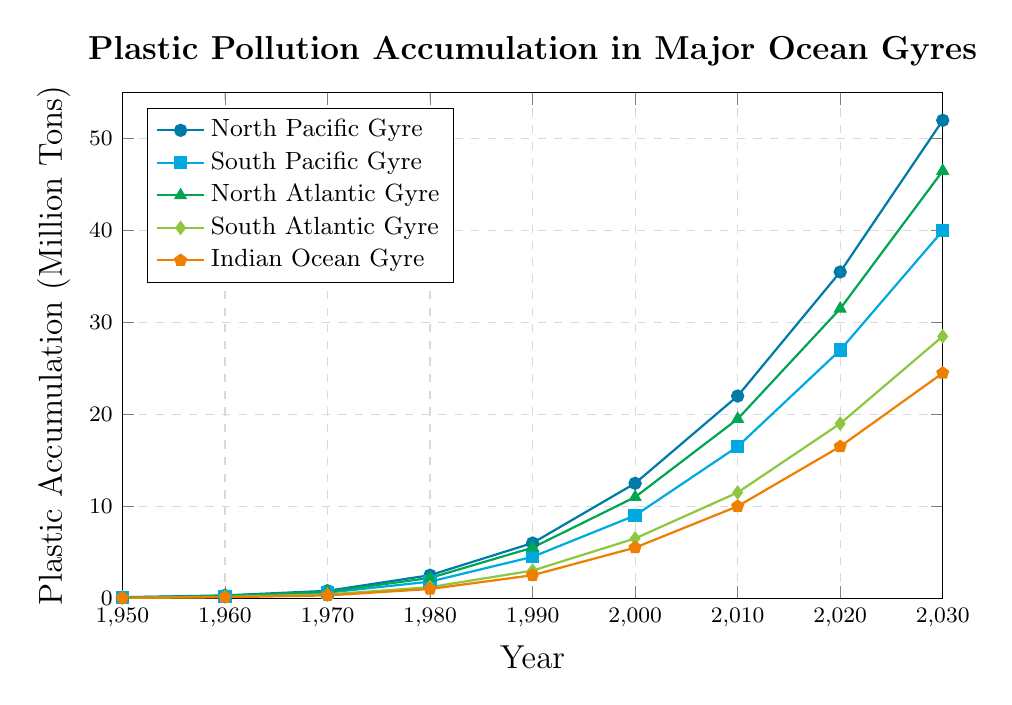What is the plastic accumulation in the North Pacific Gyre in 2020? Look for the data point corresponding to the North Pacific Gyre in the year 2020.
Answer: 35.5 million tons Which gyre has the highest plastic accumulation in the year 2030? Compare the plastic accumulation values of all gyres in the year 2030.
Answer: North Pacific Gyre What is the difference in plastic accumulation between the South Pacific Gyre and the Indian Ocean Gyre in 1980? Find the values for the South Pacific Gyre and the Indian Ocean Gyre in 1980 and calculate their difference: 1.8 - 1.0
Answer: 0.8 million tons Which gyre exhibited the largest increase in plastic accumulation from 2000 to 2010? Calculate the increase for each gyre from 2000 to 2010 and compare these values: North Pacific Gyre (22.0-12.5), South Pacific Gyre (16.5-9.0), North Atlantic Gyre (19.5-11.0), South Atlantic Gyre (11.5-6.5), Indian Ocean Gyre (10.0-5.5)
Answer: North Pacific Gyre What is the total plastic accumulation across all gyres in 1990? Sum the plastic accumulation values for all gyres in 1990: 6.0 + 4.5 + 5.5 + 3.0 + 2.5
Answer: 21.5 million tons Between 1970 and 1990, which gyre had the smallest absolute increase in plastic accumulation? Calculate the absolute increase for each gyre between 1970 and 1990: North Pacific Gyre (6.0-0.8), South Pacific Gyre (4.5-0.6), North Atlantic Gyre (5.5-0.7), South Atlantic Gyre (3.0-0.4), Indian Ocean Gyre (2.5-0.3). Identify the smallest increase
Answer: Indian Ocean Gyre What can be inferred about the trend of plastic accumulation in the North Atlantic Gyre from 1950 to 2030? Observe the trend of the North Atlantic Gyre data points over time from 1950 to 2030.
Answer: Increasing trend How many times greater is the plastic accumulation in the South Atlantic Gyre in 2020 compared to 1960? Calculate the ratio of plastic accumulation in the South Atlantic Gyre in 2020 to that in 1960: 19.0 / 0.15
Answer: Approximately 126.7 times What's the average plastic accumulation in the Indian Ocean Gyre from 1950 to 2030? Add up the values for the Indian Ocean Gyre between 1950 and 2030 and divide by the number of years: (0.02 + 0.1 + 0.3 + 1.0 + 2.5 + 5.5 + 10.0 + 16.5 + 24.5) / 9
Answer: Approximately 6.82 million tons 